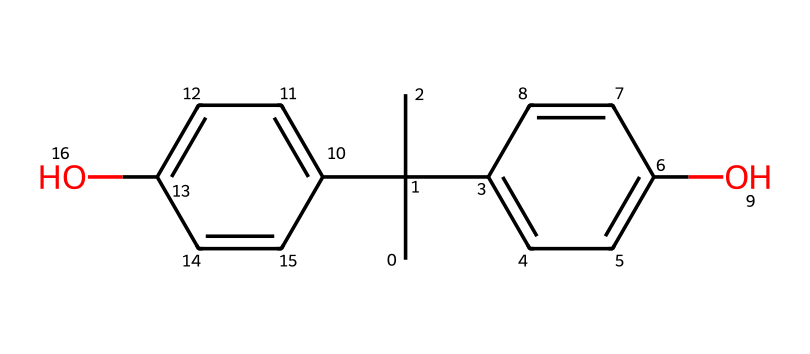What is the chemical name of the structure represented by the SMILES? The provided SMILES shows a chemical structure consisting of two phenolic groups connected by a central carbon atom, which identifies it as bisphenol A.
Answer: bisphenol A How many hydroxyl groups are present in the structure? Analyzing the structure, there are two -OH groups attached to the aromatic rings, indicating the presence of two hydroxyl groups.
Answer: 2 What is the total number of carbon atoms in this chemical structure? Counting the number of carbon atoms from the SMILES representation, there are a total of 15 carbon atoms present in the structure.
Answer: 15 What type of chemical bonds are primarily found in bisphenol A? The structure contains primarily covalent bonds between the carbon atoms and between the carbon and hydroxyl groups, indicating it is made of covalent bonds.
Answer: covalent Which functional groups are present in bisphenol A? The analysis of the structure reveals the presence of hydroxyl (-OH) functional groups, which are characteristic of phenols.
Answer: hydroxyl groups Is bisphenol A considered a toxic chemical? Research shows that bisphenol A is classified as an endocrine disruptor, leading to its reputation as a potentially toxic chemical.
Answer: yes What type of polymer is commonly produced using bisphenol A? Bisphenol A is known to be a key component in the production of polycarbonate plastics and epoxy resins, which are types of polymers.
Answer: polycarbonate 